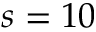Convert formula to latex. <formula><loc_0><loc_0><loc_500><loc_500>s = 1 0</formula> 